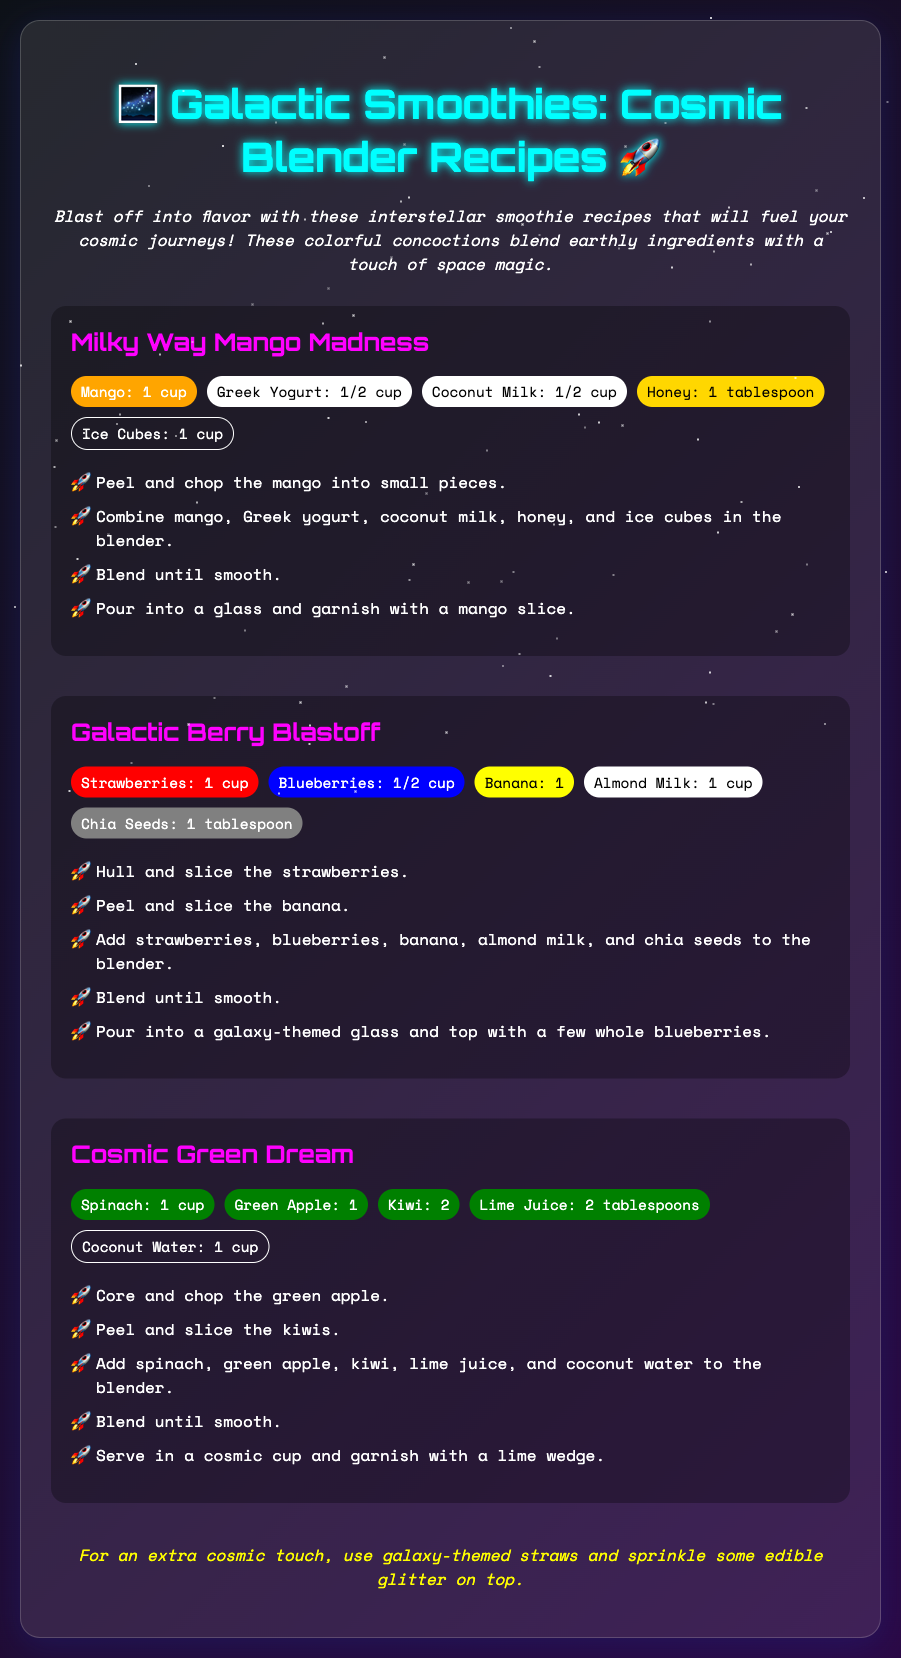What is the title of the document? The title can be found at the top of the rendered document, which is related to smoothie recipes for space adventures.
Answer: Galactic Smoothies: Cosmic Blender Recipes How many recipes are included? The document features three distinct recipes for smoothies.
Answer: 3 What ingredient is primarily used in the Milky Way Mango Madness? This ingredient is mentioned first among the ingredients in the recipe.
Answer: Mango What type of milk is used in the Galactic Berry Blastoff? The ingredient list specifies the type of milk used in this recipe.
Answer: Almond Milk What is the main fruit in the Cosmic Green Dream? This fruit is one of the main ingredients listed in the recipe among other green ingredients.
Answer: Green Apple How many tablespoons of lime juice are needed for the Cosmic Green Dream? The required amount of lime juice is explicitly stated in the ingredients section of this recipe.
Answer: 2 tablespoons What unique tip is provided for serving the smoothies? The document offers a creative suggestion to enhance the presentation of the smoothies.
Answer: Galaxy-themed straws and sprinkle some edible glitter What color is the background gradient of the document? The background gradient consists of two colors as outlined in the CSS styles.
Answer: From dark to light (0d1117 to 2a0845) 